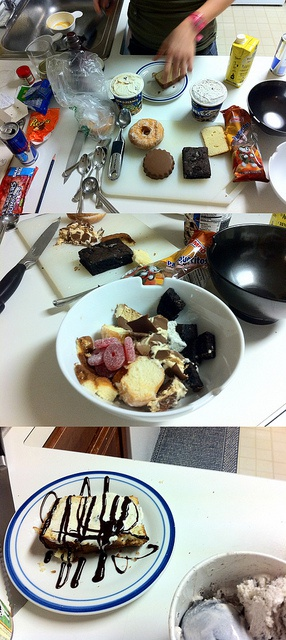Describe the objects in this image and their specific colors. I can see dining table in white, black, gray, and darkgray tones, dining table in white, lightgray, gray, darkgray, and black tones, bowl in white, lightblue, black, gray, and khaki tones, dining table in white, darkgray, and gray tones, and bowl in white, darkgray, lightgray, and gray tones in this image. 